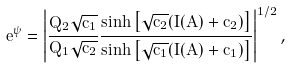<formula> <loc_0><loc_0><loc_500><loc_500>e ^ { \psi } = \left | \frac { Q _ { 2 } \sqrt { c _ { 1 } } } { Q _ { 1 } \sqrt { c _ { 2 } } } \frac { \sinh \left [ \sqrt { c _ { 2 } } ( I ( A ) + \tilde { c } _ { 2 } ) \right ] } { \sinh \left [ \sqrt { c _ { 1 } } ( I ( A ) + \tilde { c } _ { 1 } ) \right ] } \right | ^ { 1 / 2 } ,</formula> 